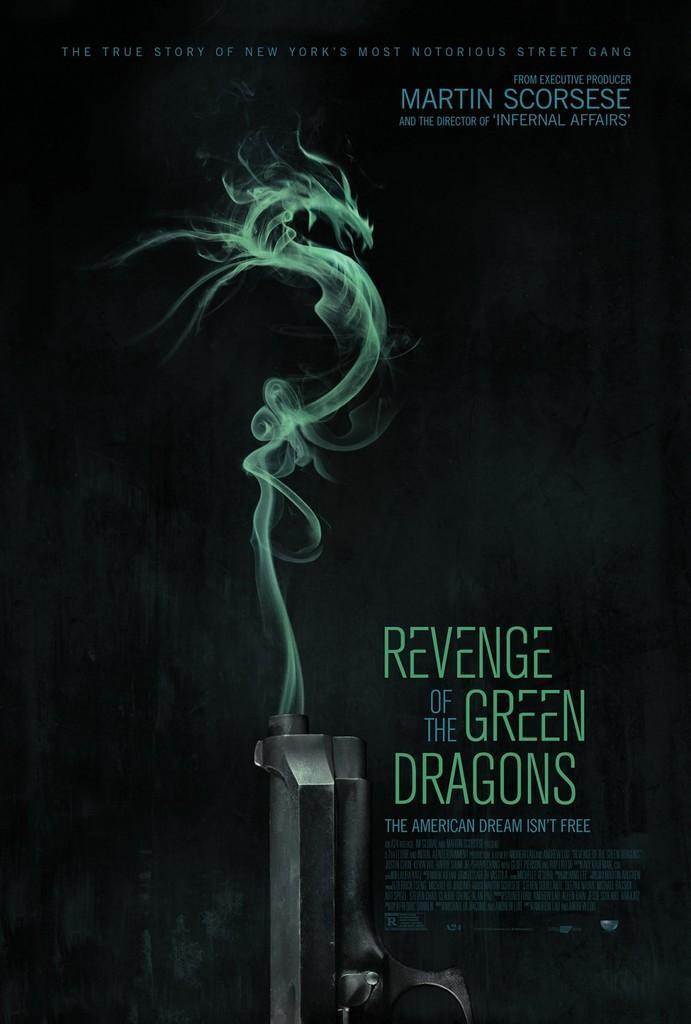Can you describe this image briefly? This is a graphic image, there is a gun at the bottom with smoke coming out of it with text on the right side and above. 